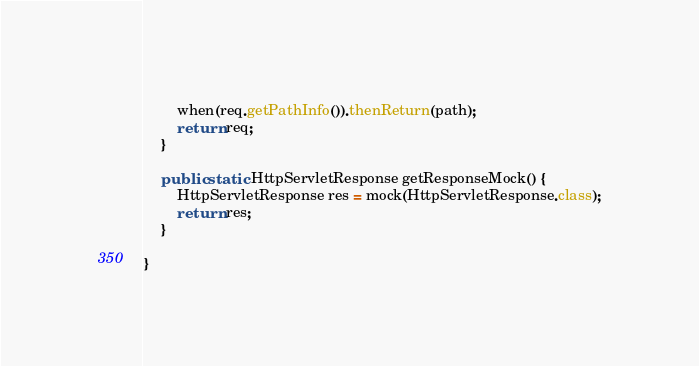<code> <loc_0><loc_0><loc_500><loc_500><_Java_>        when(req.getPathInfo()).thenReturn(path);
        return req;
    }
    
    public static HttpServletResponse getResponseMock() {
        HttpServletResponse res = mock(HttpServletResponse.class);
        return res;
    }

}
</code> 